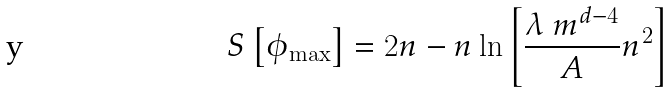Convert formula to latex. <formula><loc_0><loc_0><loc_500><loc_500>S \left [ \phi _ { \max } \right ] = 2 n - n \ln { \left [ { \frac { \lambda \ m ^ { d - 4 } } { A } } n ^ { 2 } \right ] }</formula> 